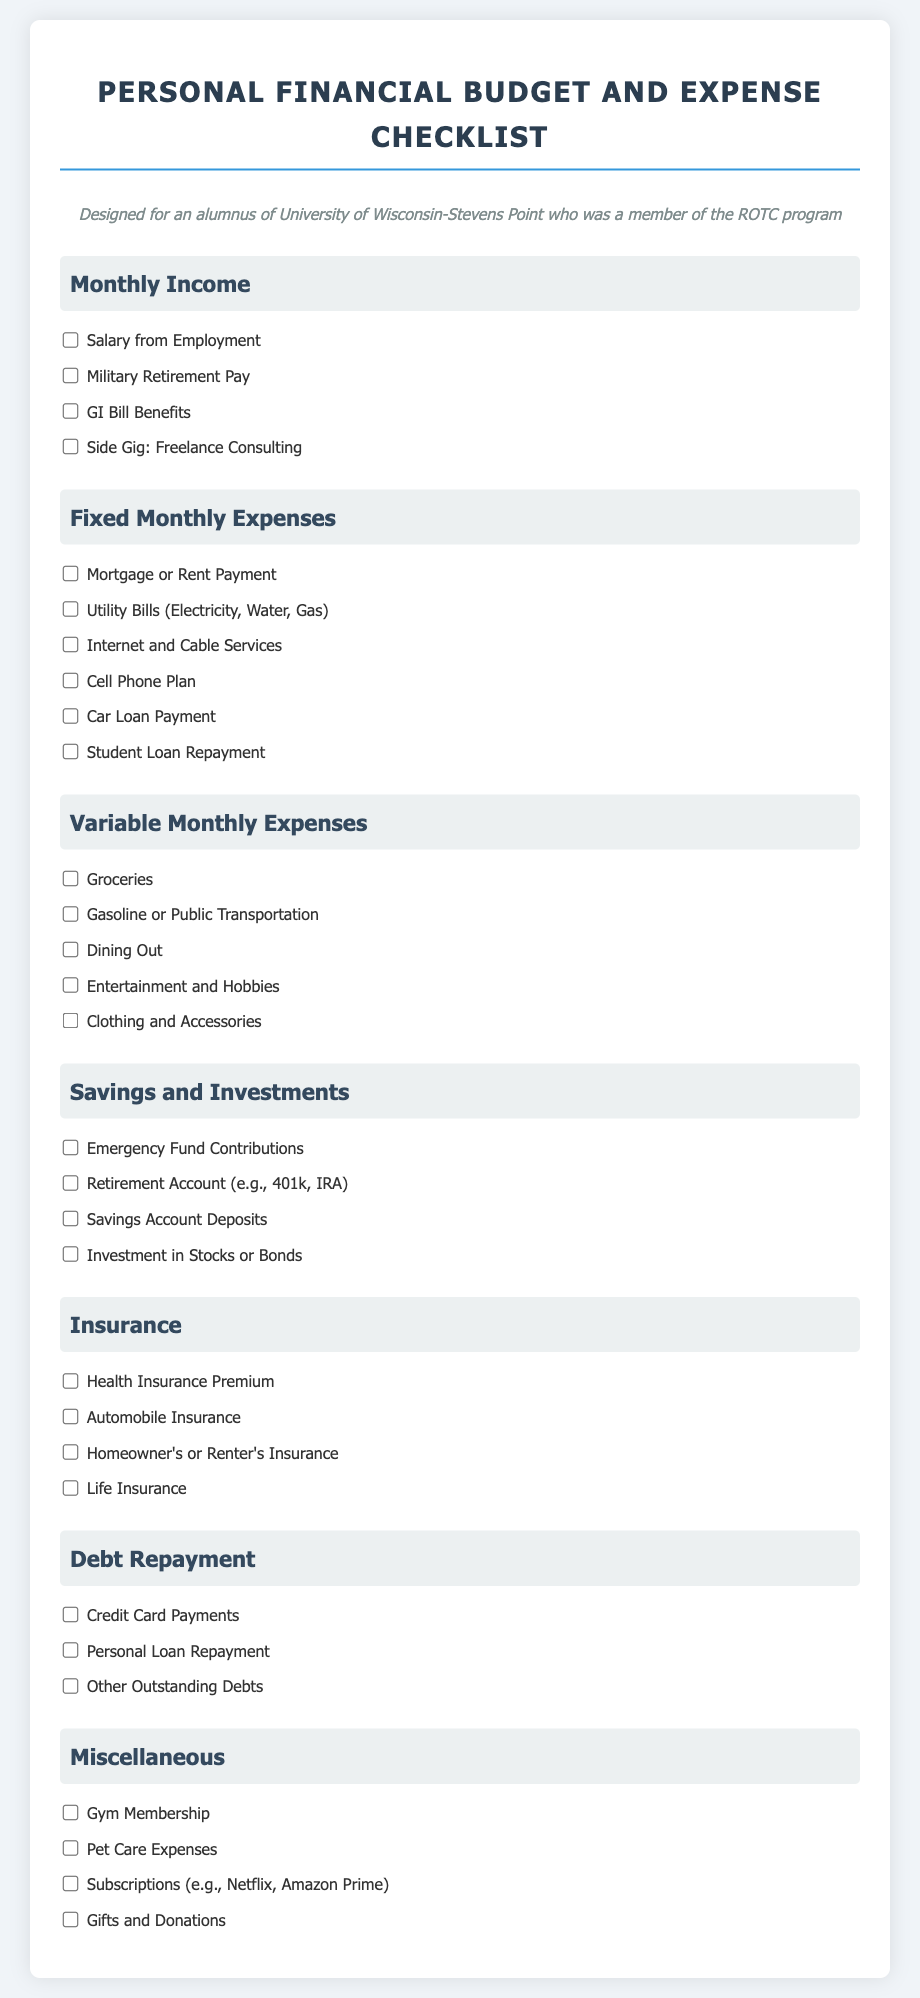What are the income sources listed? The document lists four income sources under "Monthly Income": Salary from Employment, Military Retirement Pay, GI Bill Benefits, and Side Gig: Freelance Consulting.
Answer: Salary from Employment, Military Retirement Pay, GI Bill Benefits, Side Gig: Freelance Consulting How many types of monthly expenses are categorized? The document categorizes expenses into five types: Fixed Monthly Expenses, Variable Monthly Expenses, Savings and Investments, Insurance, and Debt Repayment.
Answer: Five What is included under Fixed Monthly Expenses? The section "Fixed Monthly Expenses" includes Mortgage or Rent Payment, Utility Bills, Internet and Cable Services, Cell Phone Plan, Car Loan Payment, and Student Loan Repayment.
Answer: Mortgage or Rent Payment, Utility Bills, Internet and Cable Services, Cell Phone Plan, Car Loan Payment, Student Loan Repayment Which section covers savings? The "Savings and Investments" section discusses various savings options such as Emergency Fund Contributions, Retirement Account, Savings Account Deposits, and Investment in Stocks or Bonds.
Answer: Savings and Investments What types of insurance are listed? The document lists four types of insurance: Health Insurance Premium, Automobile Insurance, Homeowner's or Renter's Insurance, and Life Insurance under the Insurance section.
Answer: Health Insurance Premium, Automobile Insurance, Homeowner's or Renter's Insurance, Life Insurance How many items are in the Miscellaneous section? There are four items listed in the Miscellaneous section, which includes Gym Membership, Pet Care Expenses, Subscriptions, and Gifts and Donations.
Answer: Four Are there any expenses related to dining out? Yes, the document includes "Dining Out" under the "Variable Monthly Expenses" section.
Answer: Yes What is the purpose of the checklist? The checklist is designed for efficient financial management by organizing income, expenses, savings, and other financial elements.
Answer: Efficient financial management 